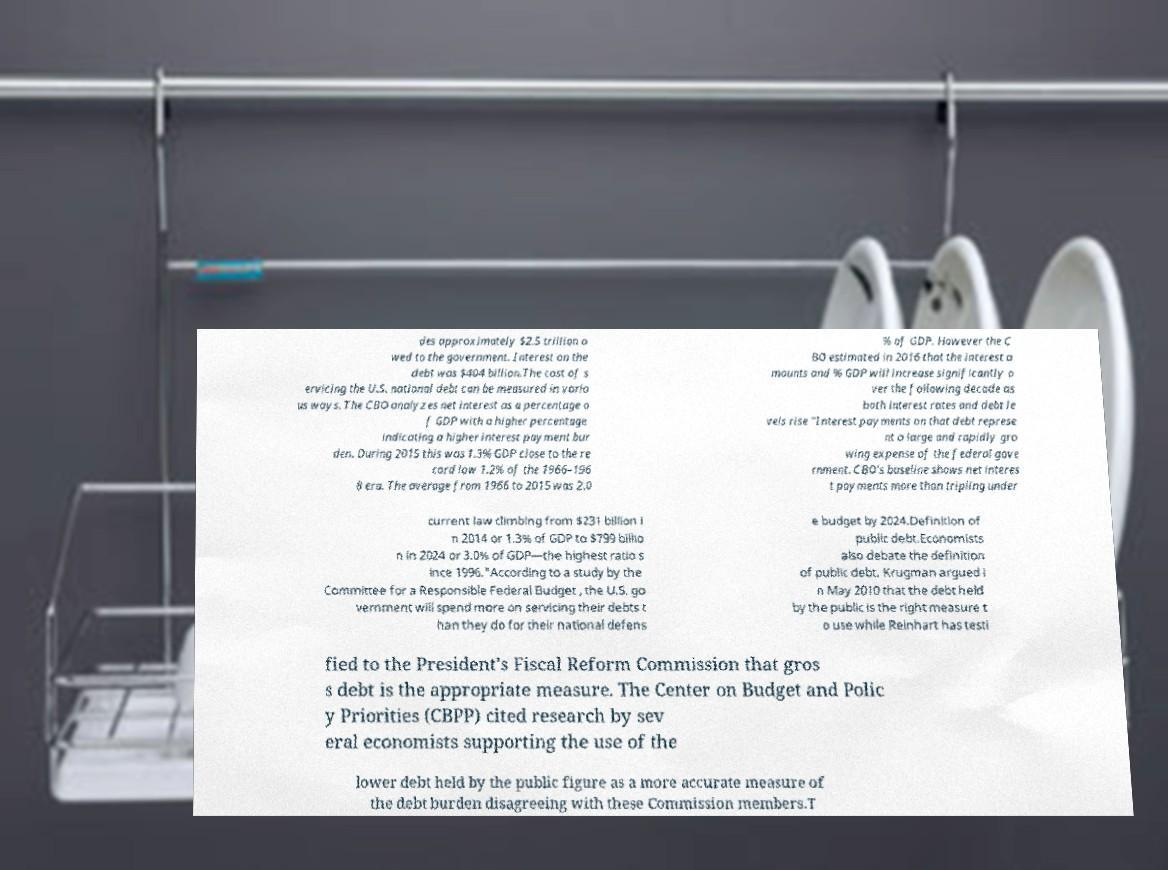I need the written content from this picture converted into text. Can you do that? des approximately $2.5 trillion o wed to the government. Interest on the debt was $404 billion.The cost of s ervicing the U.S. national debt can be measured in vario us ways. The CBO analyzes net interest as a percentage o f GDP with a higher percentage indicating a higher interest payment bur den. During 2015 this was 1.3% GDP close to the re cord low 1.2% of the 1966–196 8 era. The average from 1966 to 2015 was 2.0 % of GDP. However the C BO estimated in 2016 that the interest a mounts and % GDP will increase significantly o ver the following decade as both interest rates and debt le vels rise "Interest payments on that debt represe nt a large and rapidly gro wing expense of the federal gove rnment. CBO's baseline shows net interes t payments more than tripling under current law climbing from $231 billion i n 2014 or 1.3% of GDP to $799 billio n in 2024 or 3.0% of GDP—the highest ratio s ince 1996."According to a study by the Committee for a Responsible Federal Budget , the U.S. go vernment will spend more on servicing their debts t han they do for their national defens e budget by 2024.Definition of public debt.Economists also debate the definition of public debt. Krugman argued i n May 2010 that the debt held by the public is the right measure t o use while Reinhart has testi fied to the President's Fiscal Reform Commission that gros s debt is the appropriate measure. The Center on Budget and Polic y Priorities (CBPP) cited research by sev eral economists supporting the use of the lower debt held by the public figure as a more accurate measure of the debt burden disagreeing with these Commission members.T 